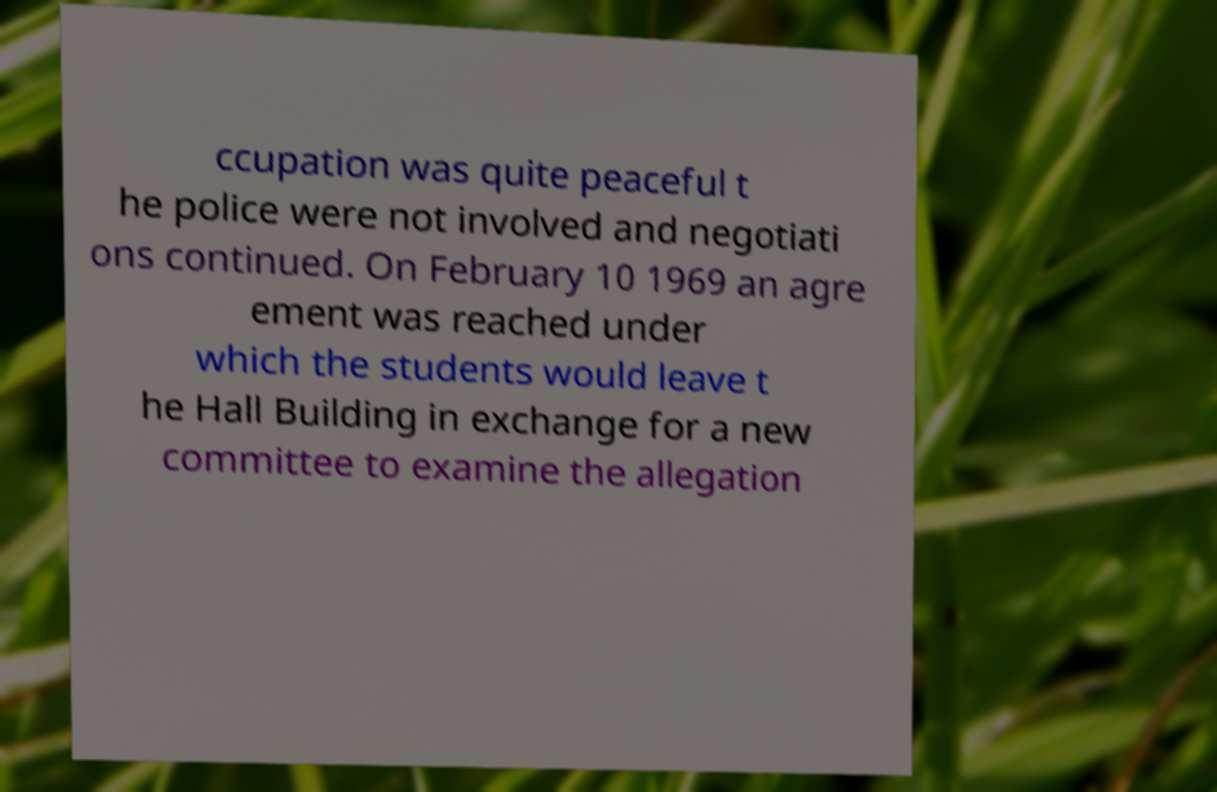Please identify and transcribe the text found in this image. ccupation was quite peaceful t he police were not involved and negotiati ons continued. On February 10 1969 an agre ement was reached under which the students would leave t he Hall Building in exchange for a new committee to examine the allegation 